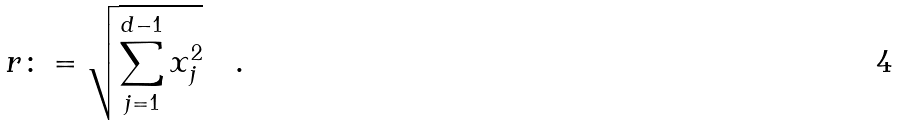Convert formula to latex. <formula><loc_0><loc_0><loc_500><loc_500>r \colon = \sqrt { \sum _ { j = 1 } ^ { d - 1 } x _ { j } ^ { 2 } } \quad .</formula> 